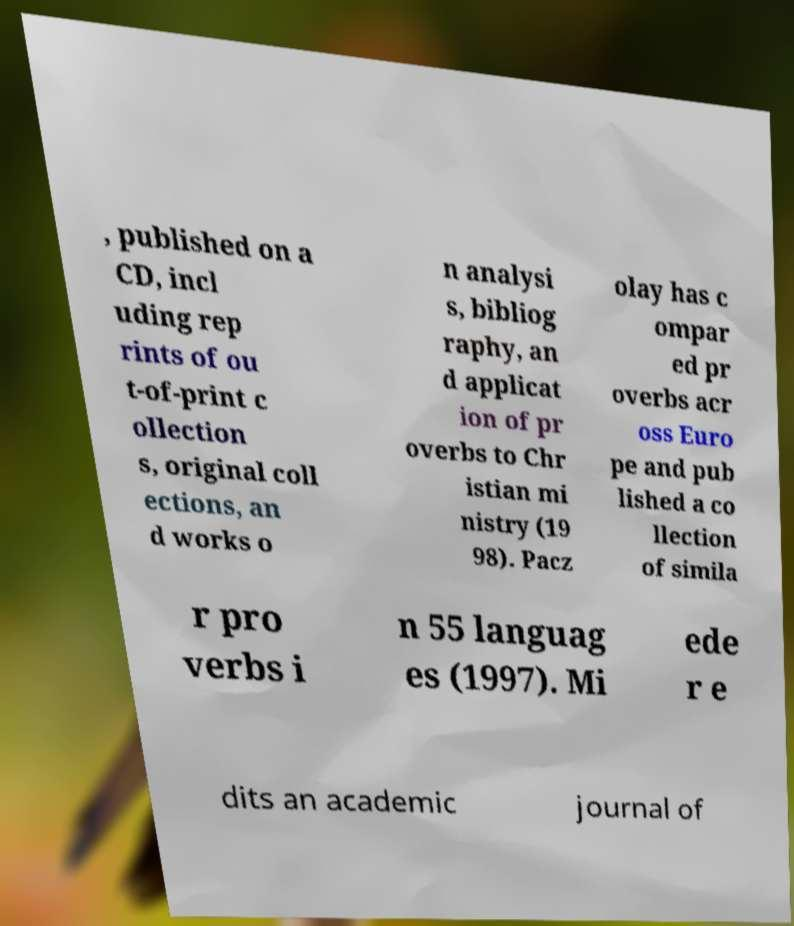Can you accurately transcribe the text from the provided image for me? , published on a CD, incl uding rep rints of ou t-of-print c ollection s, original coll ections, an d works o n analysi s, bibliog raphy, an d applicat ion of pr overbs to Chr istian mi nistry (19 98). Pacz olay has c ompar ed pr overbs acr oss Euro pe and pub lished a co llection of simila r pro verbs i n 55 languag es (1997). Mi ede r e dits an academic journal of 